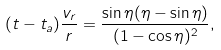<formula> <loc_0><loc_0><loc_500><loc_500>( t - t _ { a } ) \frac { v _ { r } } { r } = \frac { \sin { \eta } ( \eta - \sin { \eta } ) } { ( 1 - \cos { \eta } ) ^ { 2 } } , \\</formula> 